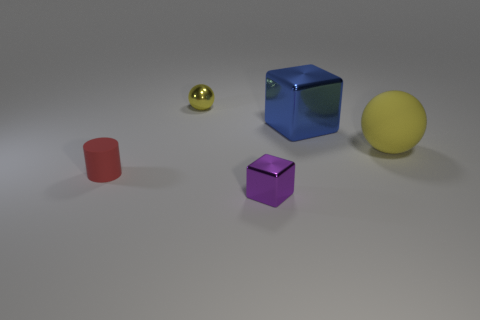Add 5 large green metal cubes. How many objects exist? 10 Subtract all cubes. How many objects are left? 3 Add 1 tiny objects. How many tiny objects are left? 4 Add 3 large cyan shiny balls. How many large cyan shiny balls exist? 3 Subtract 1 red cylinders. How many objects are left? 4 Subtract all small purple cubes. Subtract all tiny purple metallic blocks. How many objects are left? 3 